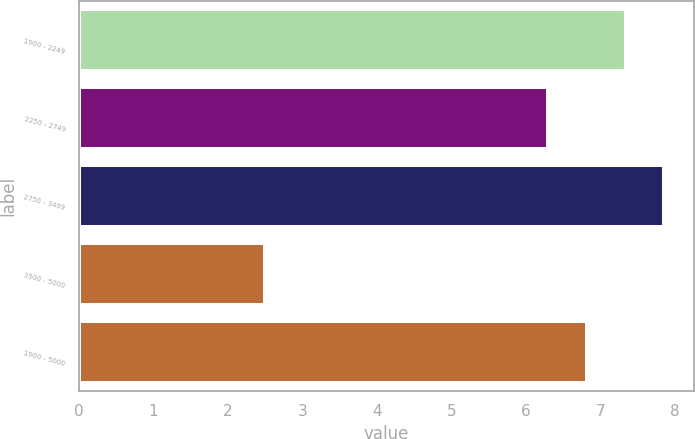<chart> <loc_0><loc_0><loc_500><loc_500><bar_chart><fcel>1900 - 2249<fcel>2250 - 2749<fcel>2750 - 3499<fcel>3500 - 5000<fcel>1900 - 5000<nl><fcel>7.34<fcel>6.3<fcel>7.86<fcel>2.5<fcel>6.82<nl></chart> 